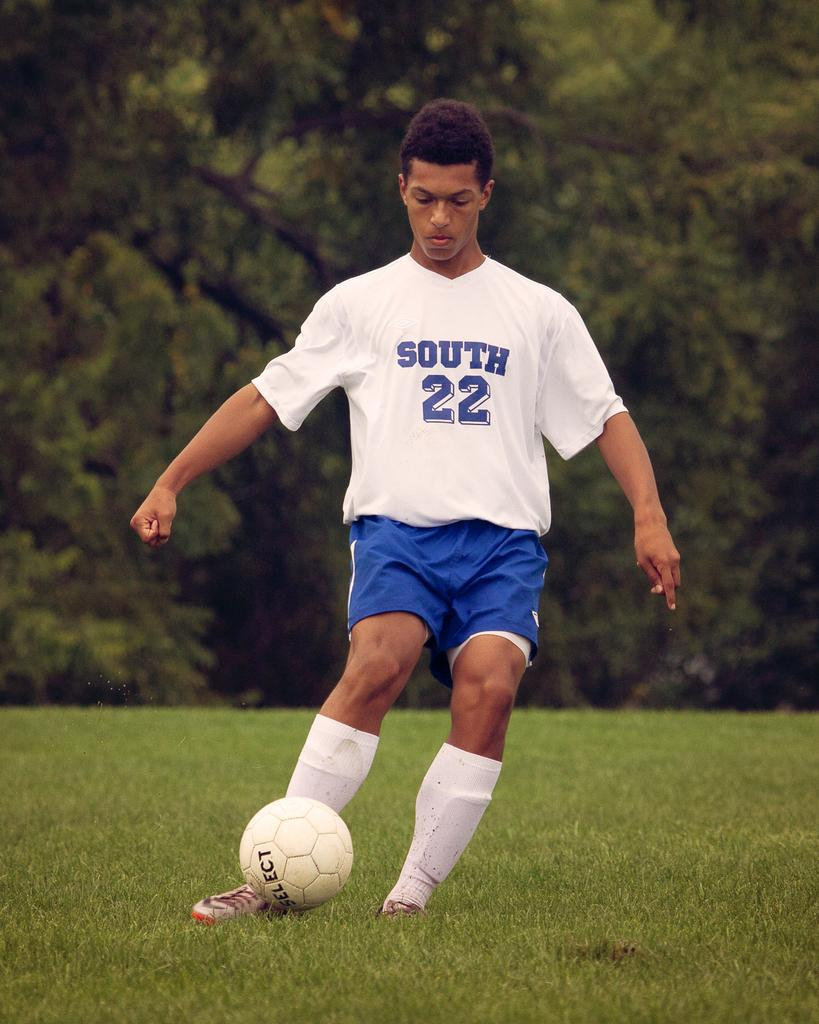Who is present in the image? There is a man in the image. What is the man wearing? The man is wearing a t-shirt. What is the man doing in the image? The man is playing. What can be seen in the background of the image? There are trees visible in the background of the image. What type of ground is visible at the bottom of the image? There is grass at the bottom of the image. How does the crowd react to the man's smile in the image? There is no crowd present in the image, and the man's smile cannot be determined from the provided facts. 